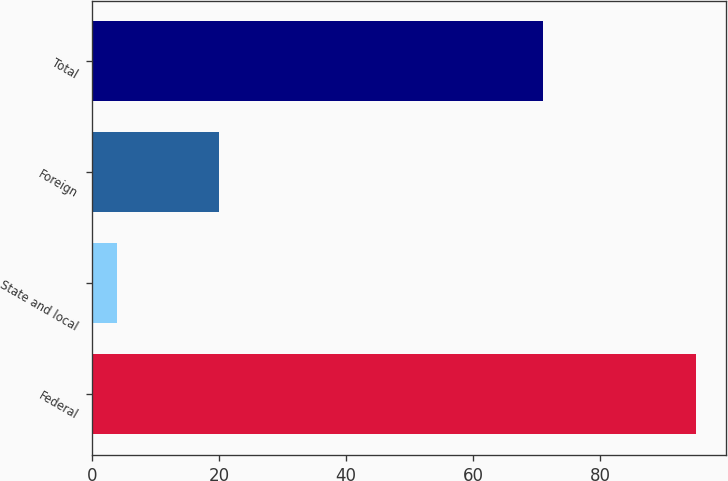<chart> <loc_0><loc_0><loc_500><loc_500><bar_chart><fcel>Federal<fcel>State and local<fcel>Foreign<fcel>Total<nl><fcel>95<fcel>4<fcel>20<fcel>71<nl></chart> 